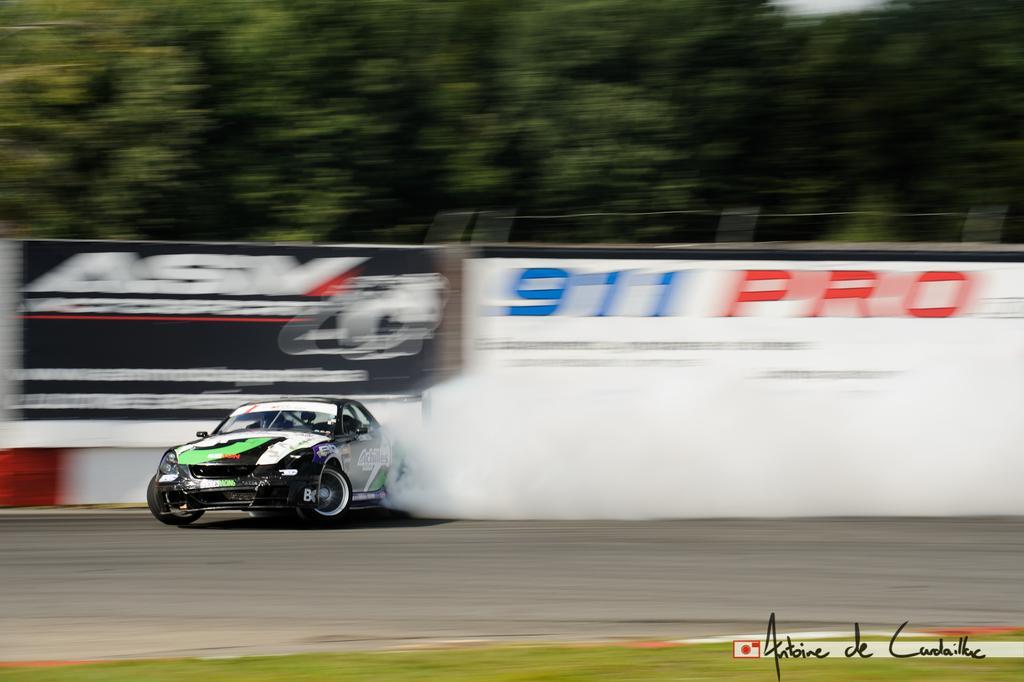How would you summarize this image in a sentence or two? In the center of the image we can see a car on the road. On the right there is a smoke. In the background there are boards and trees. 